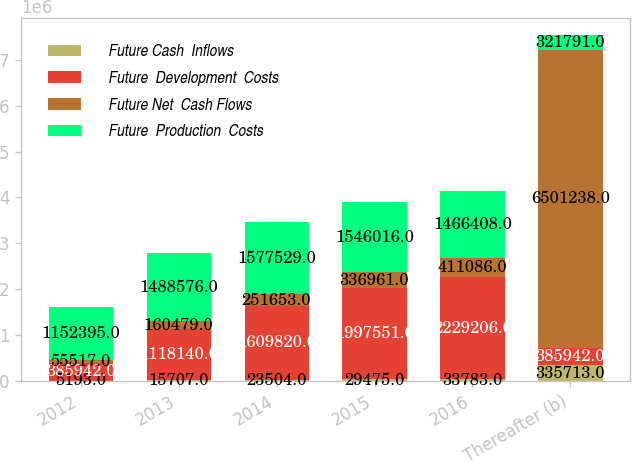<chart> <loc_0><loc_0><loc_500><loc_500><stacked_bar_chart><ecel><fcel>2012<fcel>2013<fcel>2014<fcel>2015<fcel>2016<fcel>Thereafter (b)<nl><fcel>Future Cash  Inflows<fcel>5193<fcel>15707<fcel>23504<fcel>29475<fcel>33783<fcel>335713<nl><fcel>Future  Development  Costs<fcel>385942<fcel>1.11814e+06<fcel>1.60982e+06<fcel>1.99755e+06<fcel>2.22921e+06<fcel>385942<nl><fcel>Future Net  Cash Flows<fcel>55517<fcel>160479<fcel>251653<fcel>336961<fcel>411086<fcel>6.50124e+06<nl><fcel>Future  Production  Costs<fcel>1.1524e+06<fcel>1.48858e+06<fcel>1.57753e+06<fcel>1.54602e+06<fcel>1.46641e+06<fcel>321791<nl></chart> 